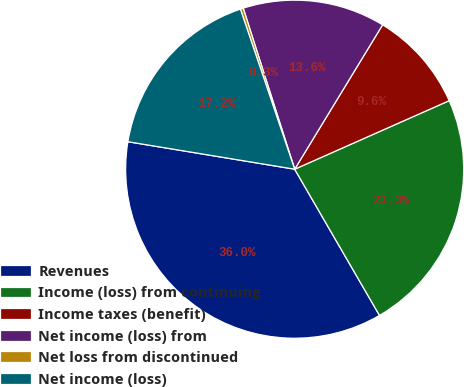Convert chart. <chart><loc_0><loc_0><loc_500><loc_500><pie_chart><fcel>Revenues<fcel>Income (loss) from continuing<fcel>Income taxes (benefit)<fcel>Net income (loss) from<fcel>Net loss from discontinued<fcel>Net income (loss)<nl><fcel>35.97%<fcel>23.28%<fcel>9.65%<fcel>13.63%<fcel>0.28%<fcel>17.2%<nl></chart> 